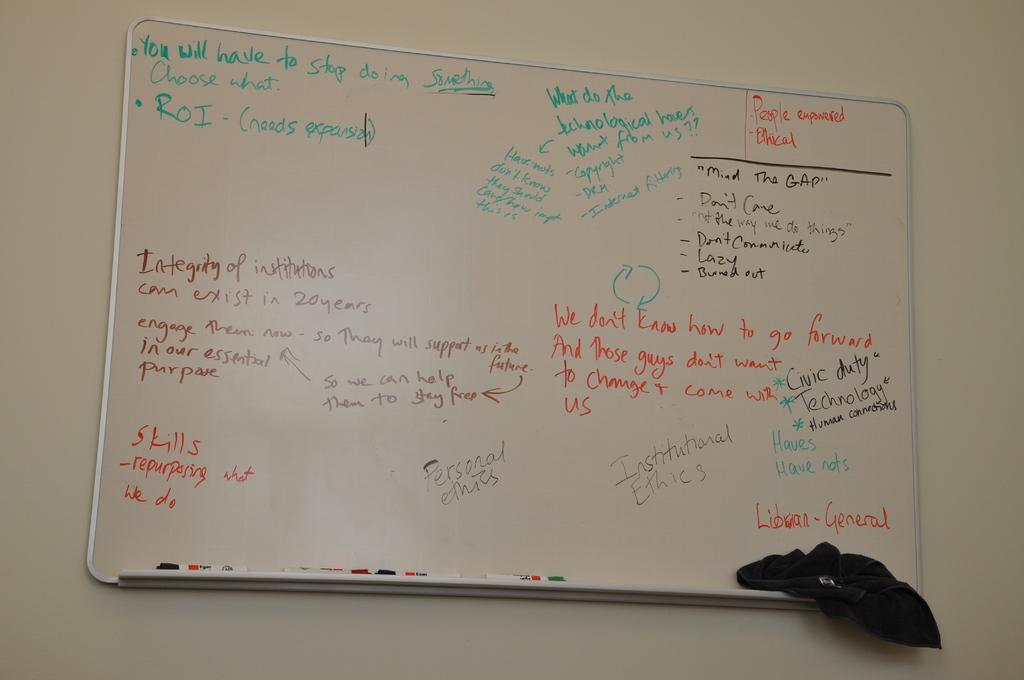Provide a one-sentence caption for the provided image. A whiteboard has people empowered written in orange at the top right corner. 